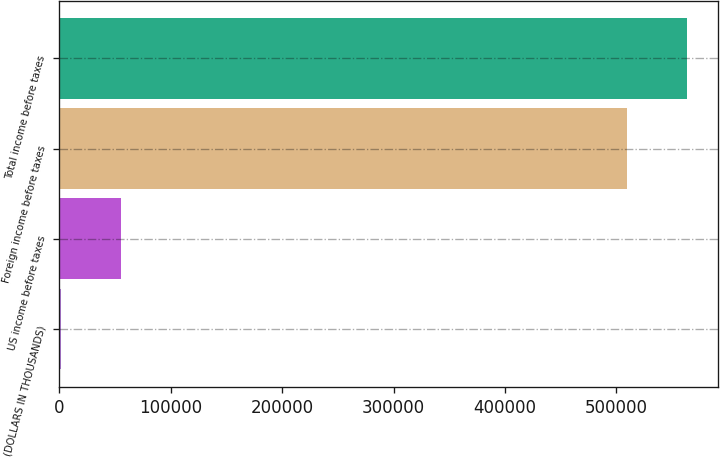<chart> <loc_0><loc_0><loc_500><loc_500><bar_chart><fcel>(DOLLARS IN THOUSANDS)<fcel>US income before taxes<fcel>Foreign income before taxes<fcel>Total income before taxes<nl><fcel>2015<fcel>55723.6<fcel>509309<fcel>563018<nl></chart> 